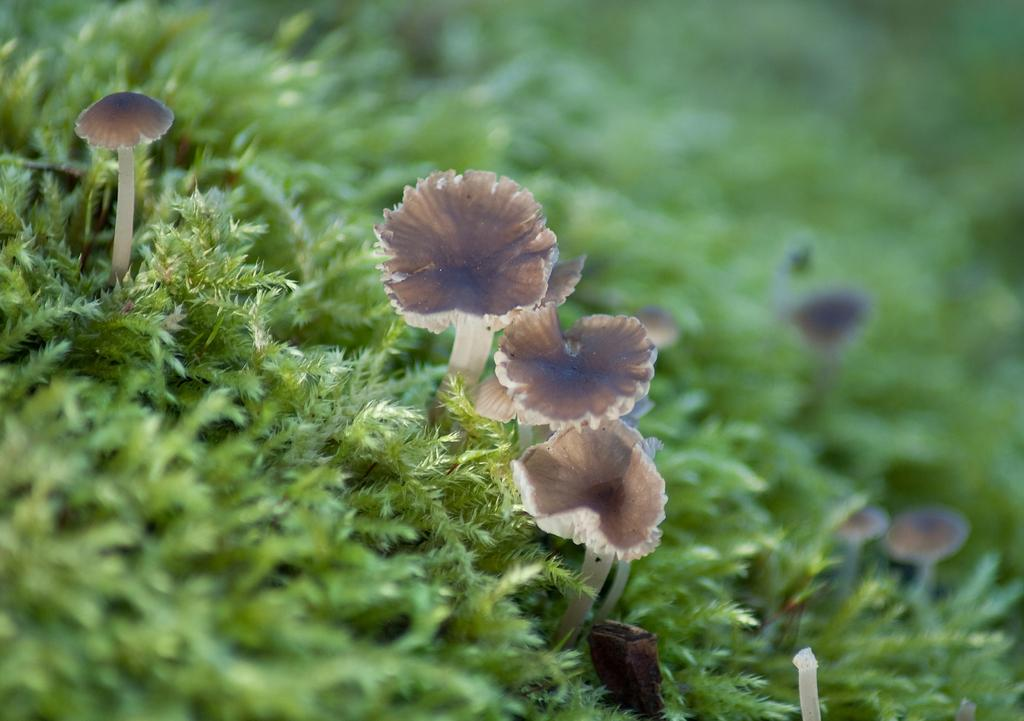What type of vegetation can be seen in the foreground of the picture? There are mushrooms and grass in the foreground of the picture. Can you describe the background of the picture? The background of the picture is blurred. What type of vegetation is present in the background of the picture? There are mushrooms and greenery in the background of the picture. What type of humor can be seen in the picture? There is no humor present in the picture; it features mushrooms and grass in the foreground and a blurred background. Can you describe the wall in the picture? There is no wall present in the picture; it primarily consists of vegetation and a blurred background. 